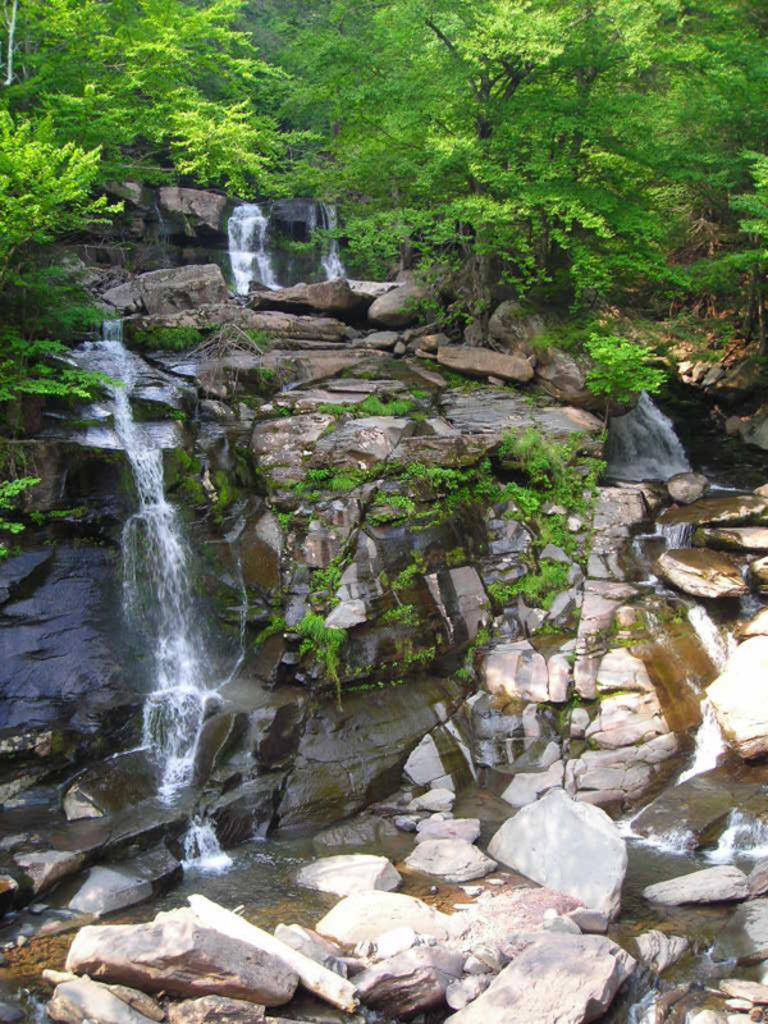Where was the picture taken? The picture was taken outside. What is the main feature in the center of the image? There is a waterfall in the center of the image. What type of natural formation can be seen in the image? Rocks are visible in the image. What color is associated with the leaves in the image? Green leaves are present in the image. What type of vegetation is visible in the image? Plants and trees are visible in the image. How does the beginner learn to blow a bun in the image? There is no reference to a beginner, blowing, or a bun in the image; it features a waterfall and natural elements. 